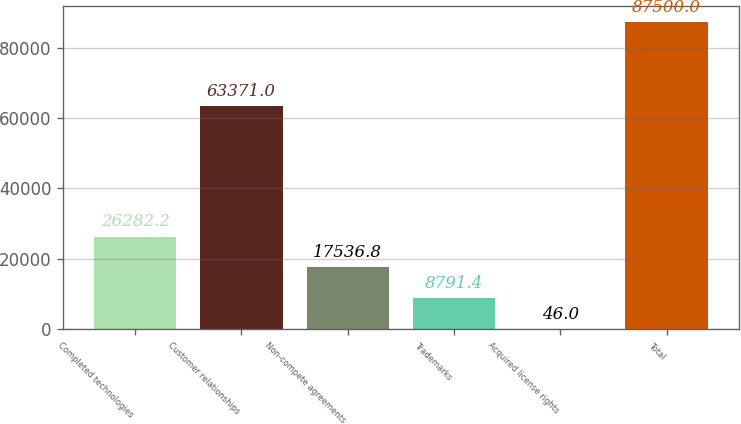Convert chart. <chart><loc_0><loc_0><loc_500><loc_500><bar_chart><fcel>Completed technologies<fcel>Customer relationships<fcel>Non-compete agreements<fcel>Trademarks<fcel>Acquired license rights<fcel>Total<nl><fcel>26282.2<fcel>63371<fcel>17536.8<fcel>8791.4<fcel>46<fcel>87500<nl></chart> 